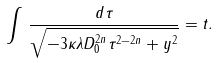Convert formula to latex. <formula><loc_0><loc_0><loc_500><loc_500>\int \, \frac { d \tau } { \sqrt { - 3 \kappa \lambda D _ { 0 } ^ { 2 n } \tau ^ { 2 - 2 n } + y ^ { 2 } } } = t .</formula> 